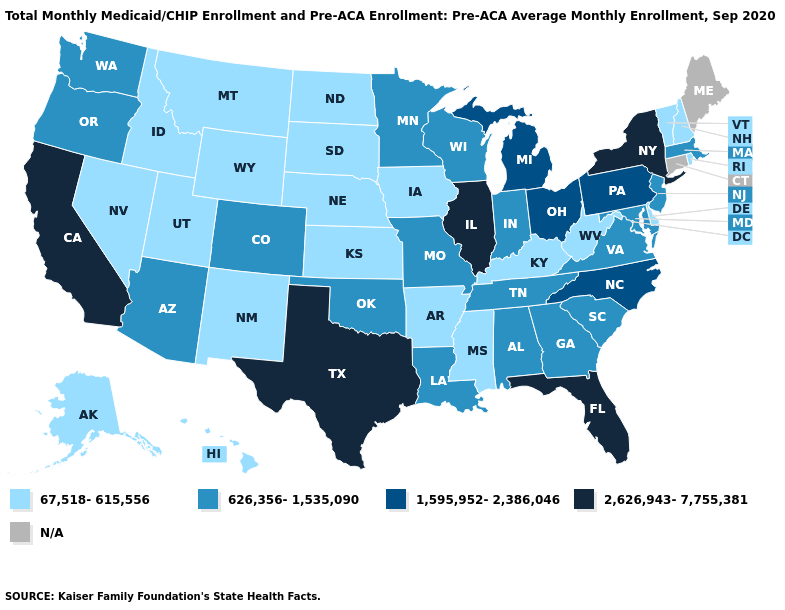What is the lowest value in the South?
Quick response, please. 67,518-615,556. Among the states that border Georgia , does Alabama have the highest value?
Short answer required. No. Does West Virginia have the lowest value in the South?
Short answer required. Yes. Among the states that border Mississippi , which have the highest value?
Quick response, please. Alabama, Louisiana, Tennessee. What is the value of Florida?
Answer briefly. 2,626,943-7,755,381. How many symbols are there in the legend?
Be succinct. 5. Which states have the highest value in the USA?
Answer briefly. California, Florida, Illinois, New York, Texas. Name the states that have a value in the range 626,356-1,535,090?
Write a very short answer. Alabama, Arizona, Colorado, Georgia, Indiana, Louisiana, Maryland, Massachusetts, Minnesota, Missouri, New Jersey, Oklahoma, Oregon, South Carolina, Tennessee, Virginia, Washington, Wisconsin. What is the lowest value in the USA?
Give a very brief answer. 67,518-615,556. What is the value of Arkansas?
Short answer required. 67,518-615,556. What is the lowest value in states that border Alabama?
Short answer required. 67,518-615,556. Does Illinois have the highest value in the USA?
Be succinct. Yes. Name the states that have a value in the range 2,626,943-7,755,381?
Concise answer only. California, Florida, Illinois, New York, Texas. Among the states that border Arkansas , does Tennessee have the highest value?
Write a very short answer. No. What is the highest value in the USA?
Answer briefly. 2,626,943-7,755,381. 